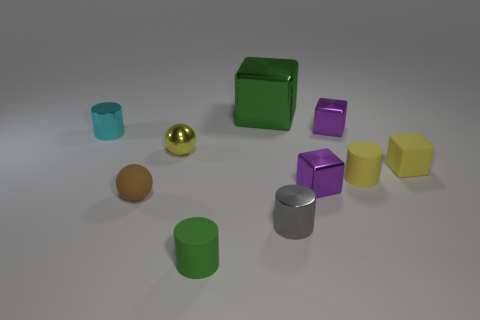Is the number of small purple objects less than the number of rubber things?
Your answer should be very brief. Yes. Are there any other things that are the same color as the tiny matte sphere?
Give a very brief answer. No. There is a matte cylinder left of the green metal object; what is its size?
Your response must be concise. Small. Are there more tiny matte balls than small cyan matte things?
Offer a terse response. Yes. What is the material of the tiny yellow cube?
Offer a terse response. Rubber. What number of other objects are the same material as the cyan object?
Your answer should be very brief. 5. What number of tiny metallic cylinders are there?
Provide a short and direct response. 2. There is a small yellow object that is the same shape as the brown thing; what material is it?
Your answer should be very brief. Metal. Does the yellow object on the left side of the big green metallic cube have the same material as the small brown thing?
Provide a succinct answer. No. Is the number of small yellow shiny spheres right of the green rubber cylinder greater than the number of small green matte cylinders behind the gray metal object?
Offer a very short reply. No. 